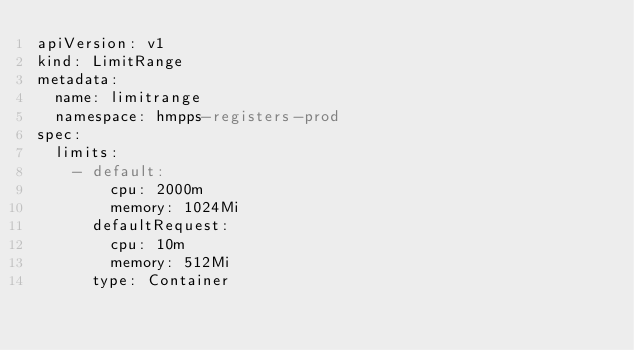<code> <loc_0><loc_0><loc_500><loc_500><_YAML_>apiVersion: v1
kind: LimitRange
metadata:
  name: limitrange
  namespace: hmpps-registers-prod
spec:
  limits:
    - default:
        cpu: 2000m
        memory: 1024Mi
      defaultRequest:
        cpu: 10m
        memory: 512Mi
      type: Container
</code> 